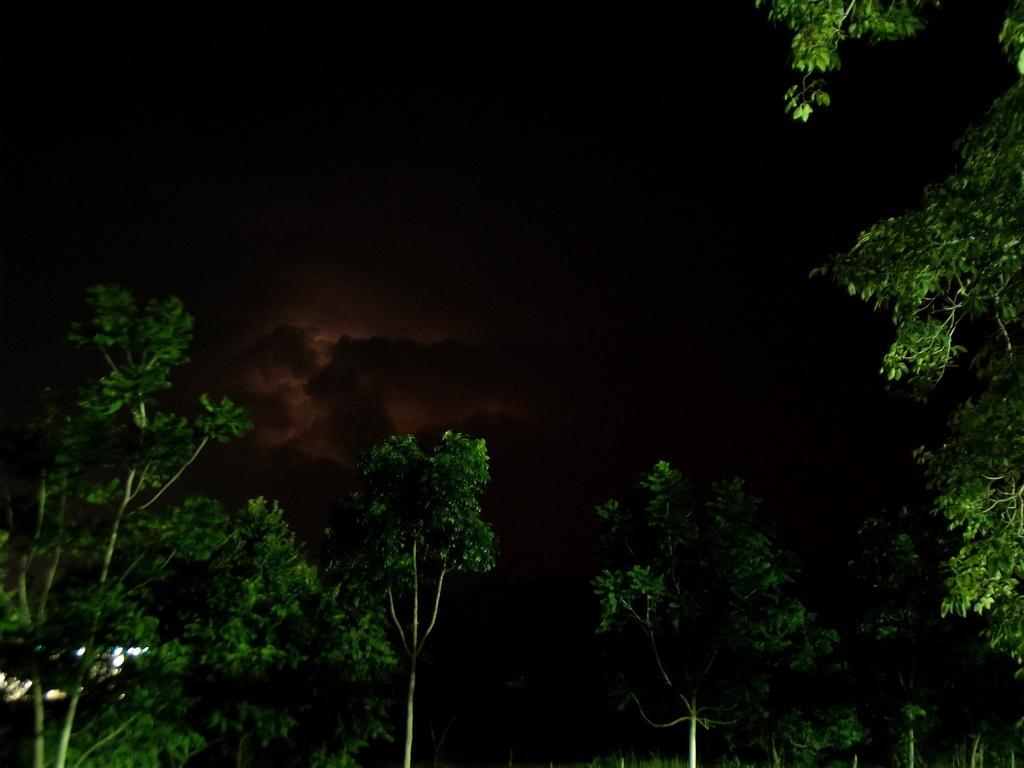In one or two sentences, can you explain what this image depicts? In this picture we can see trees, lights and in the background it is dark. 